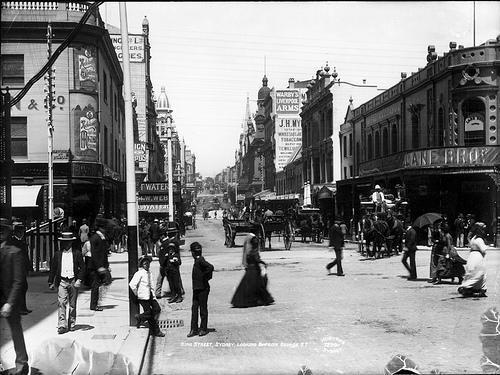How many cars are there?
Give a very brief answer. 0. How many people can you see?
Give a very brief answer. 2. 